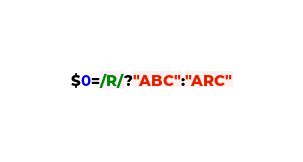<code> <loc_0><loc_0><loc_500><loc_500><_Awk_>$0=/R/?"ABC":"ARC"
</code> 